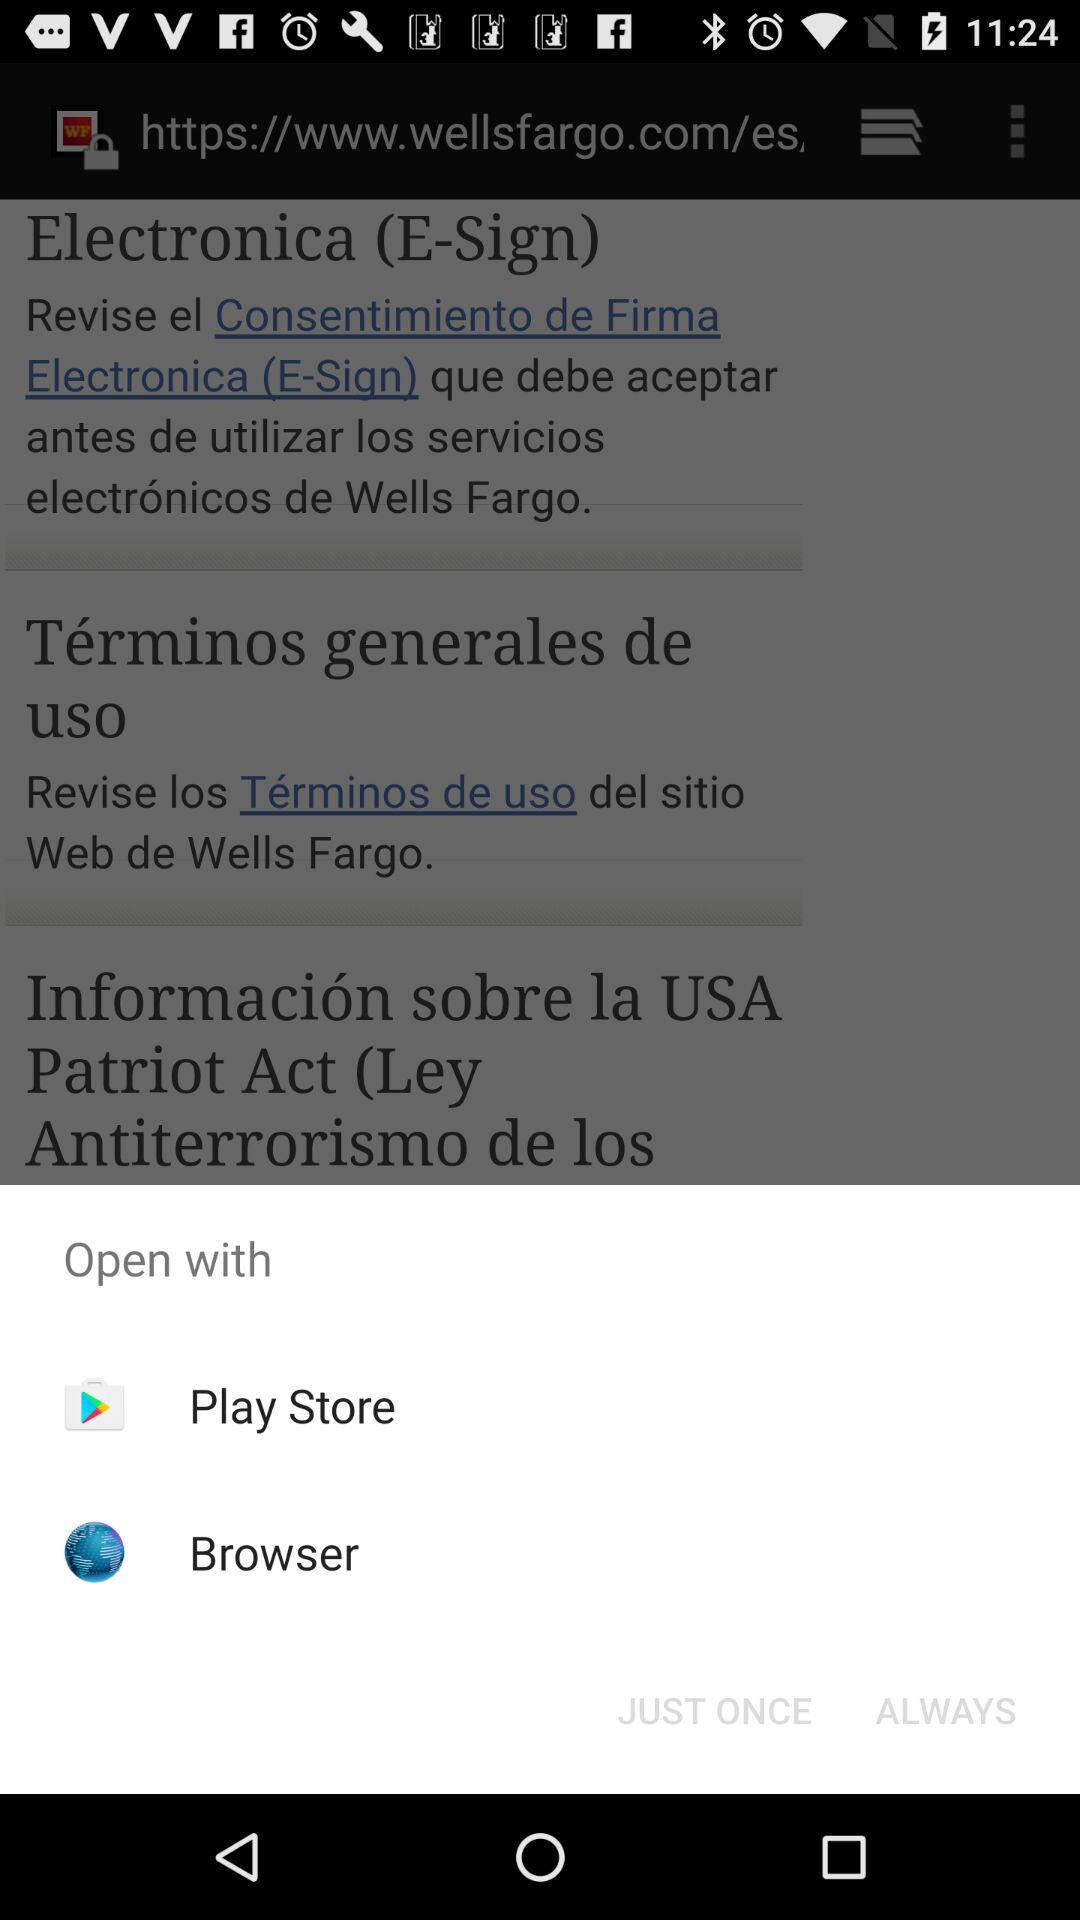What are the different options through which we can open? You can open it with the Play Store and browser. 